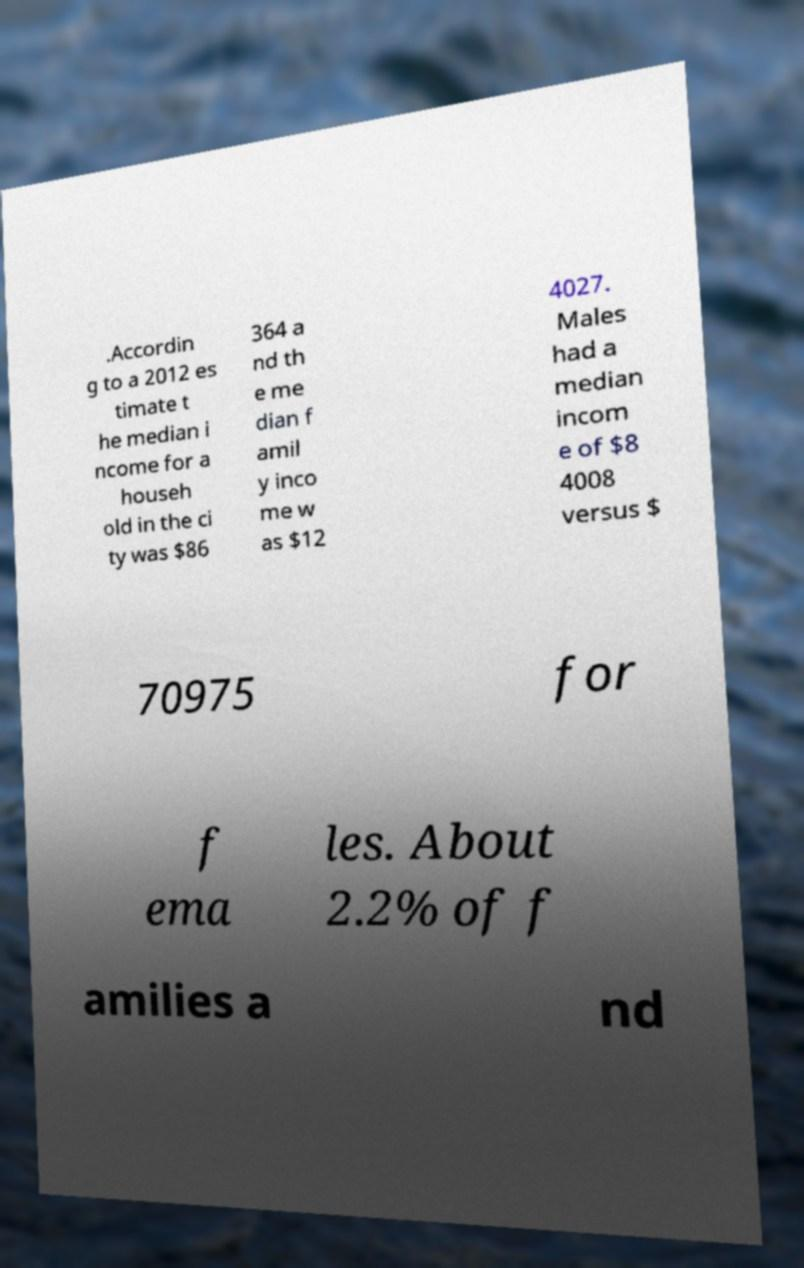There's text embedded in this image that I need extracted. Can you transcribe it verbatim? .Accordin g to a 2012 es timate t he median i ncome for a househ old in the ci ty was $86 364 a nd th e me dian f amil y inco me w as $12 4027. Males had a median incom e of $8 4008 versus $ 70975 for f ema les. About 2.2% of f amilies a nd 